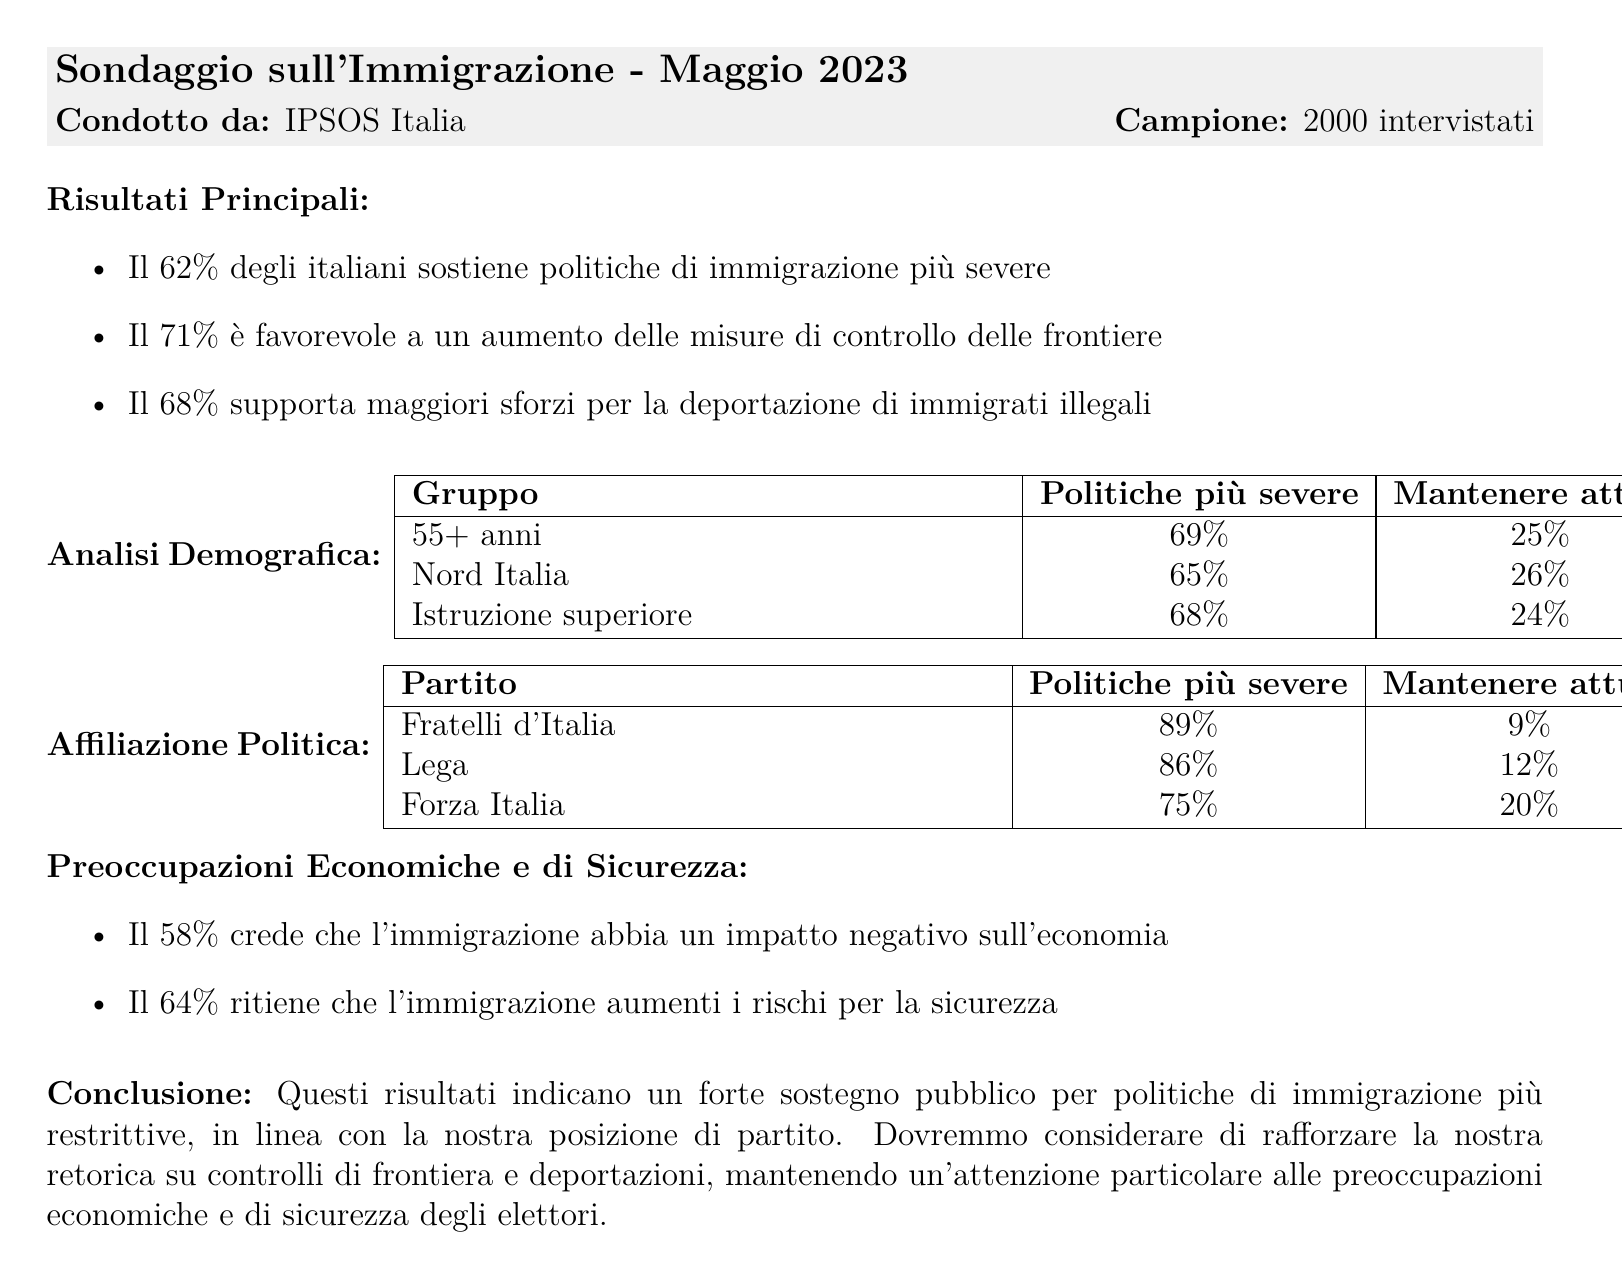What percentage of Italians support stricter immigration policies? The document states that 62% of Italians support stricter immigration policies.
Answer: 62% What is the margin of error for the poll results? The margin of error is indicated as ±2.5%.
Answer: ±2.5% Which age group shows the highest support for stricter immigration policies? The 55+ age group shows the highest support at 69%.
Answer: 55+ What percentage of Fratelli d'Italia supporters want to maintain current immigration policies? The document specifies that only 9% of Fratelli d'Italia supporters want to maintain current policies.
Answer: 9% What is the sample size of the poll conducted by IPSOS Italia? The document reveals that the sample size is 2000 respondents.
Answer: 2000 How many respondents believe that immigration increases security risks? According to the document, 64% believe immigration increases security risks.
Answer: 64% What is the support percentage for increased measures for border control? It is stated that 71% support increased measures for border control.
Answer: 71% What party shows the least support for relaxing immigration policies? The document indicates that Fratelli d'Italia shows the least support, with only 2%.
Answer: 2% What is the opinion of those with a university degree regarding stricter immigration policies? 56% of those with a university degree support stricter immigration policies.
Answer: 56% 